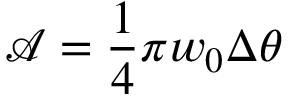Convert formula to latex. <formula><loc_0><loc_0><loc_500><loc_500>\mathcal { A } = \frac { 1 } { 4 } \pi w _ { 0 } \Delta \theta</formula> 